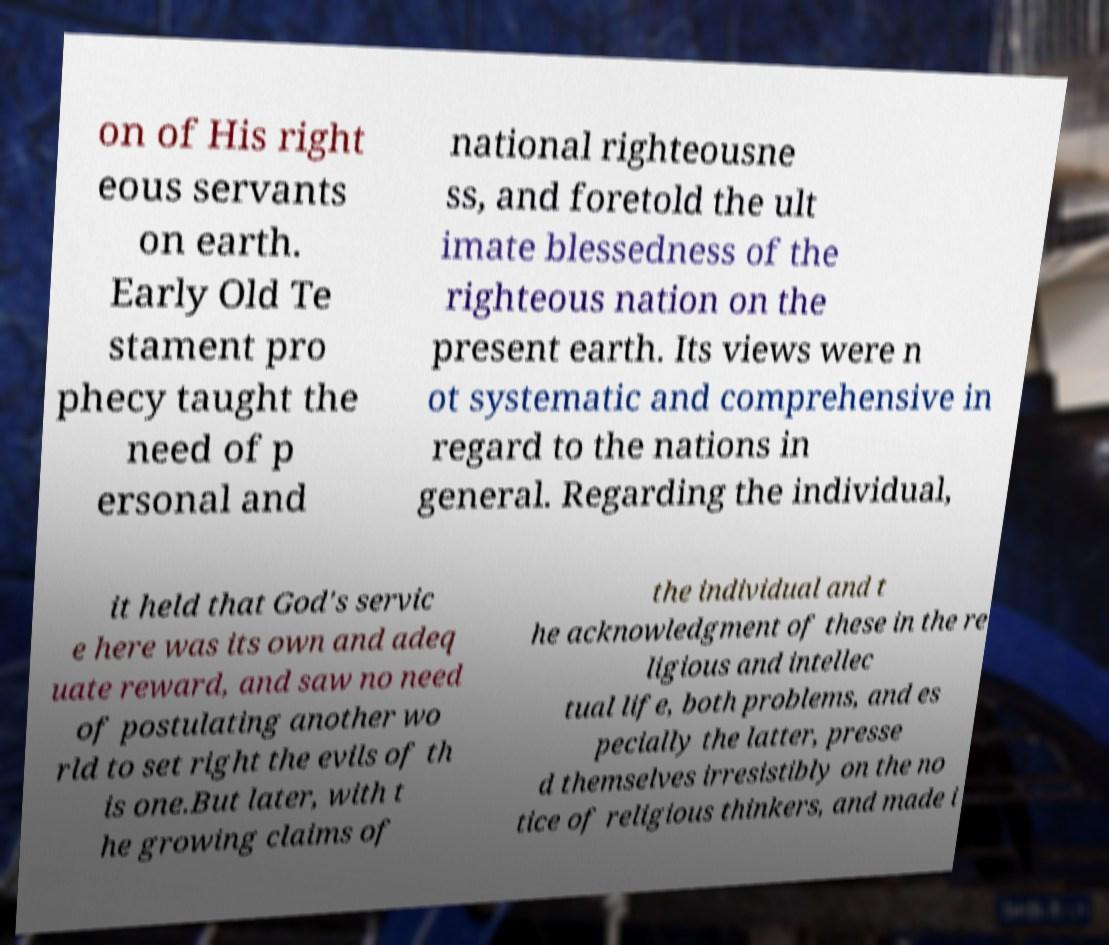Can you read and provide the text displayed in the image?This photo seems to have some interesting text. Can you extract and type it out for me? on of His right eous servants on earth. Early Old Te stament pro phecy taught the need of p ersonal and national righteousne ss, and foretold the ult imate blessedness of the righteous nation on the present earth. Its views were n ot systematic and comprehensive in regard to the nations in general. Regarding the individual, it held that God's servic e here was its own and adeq uate reward, and saw no need of postulating another wo rld to set right the evils of th is one.But later, with t he growing claims of the individual and t he acknowledgment of these in the re ligious and intellec tual life, both problems, and es pecially the latter, presse d themselves irresistibly on the no tice of religious thinkers, and made i 